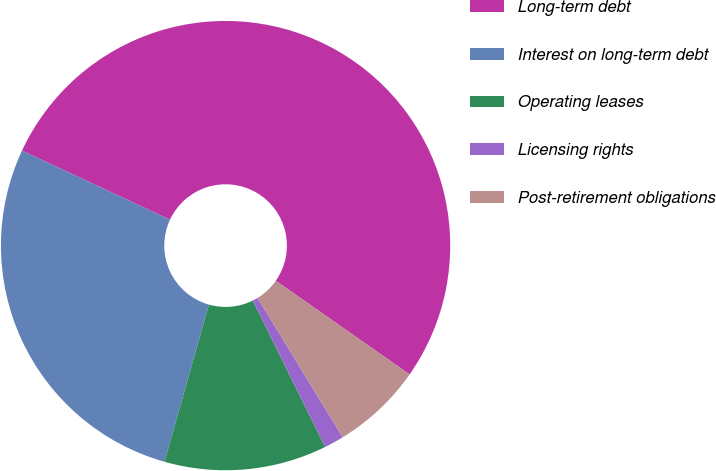<chart> <loc_0><loc_0><loc_500><loc_500><pie_chart><fcel>Long-term debt<fcel>Interest on long-term debt<fcel>Operating leases<fcel>Licensing rights<fcel>Post-retirement obligations<nl><fcel>52.77%<fcel>27.56%<fcel>11.69%<fcel>1.42%<fcel>6.55%<nl></chart> 